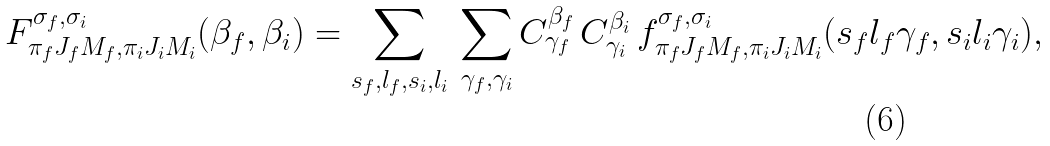Convert formula to latex. <formula><loc_0><loc_0><loc_500><loc_500>F ^ { \sigma _ { f } , \sigma _ { i } } _ { \pi _ { f } J _ { f } M _ { f } , \pi _ { i } J _ { i } M _ { i } } ( \beta _ { f } , \beta _ { i } ) = \sum _ { s _ { f } , l _ { f } , s _ { i } , l _ { i } } \, \sum _ { \gamma _ { f } , \gamma _ { i } } C ^ { \beta _ { f } } _ { \gamma _ { f } } \, C ^ { \beta _ { i } } _ { \gamma _ { i } } \, f ^ { \sigma _ { f } , \sigma _ { i } } _ { \pi _ { f } J _ { f } M _ { f } , \pi _ { i } J _ { i } M _ { i } } ( s _ { f } l _ { f } \gamma _ { f } , s _ { i } l _ { i } \gamma _ { i } ) ,</formula> 